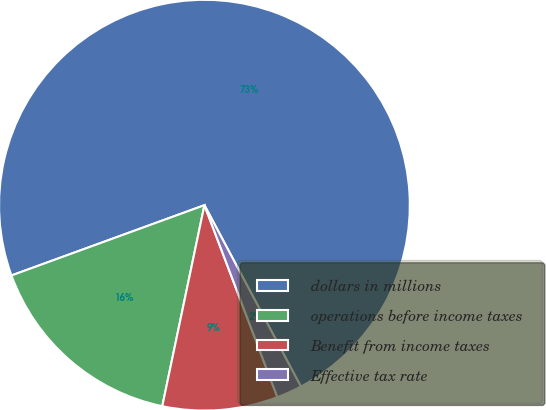Convert chart. <chart><loc_0><loc_0><loc_500><loc_500><pie_chart><fcel>dollars in millions<fcel>operations before income taxes<fcel>Benefit from income taxes<fcel>Effective tax rate<nl><fcel>72.78%<fcel>16.15%<fcel>9.07%<fcel>2.0%<nl></chart> 